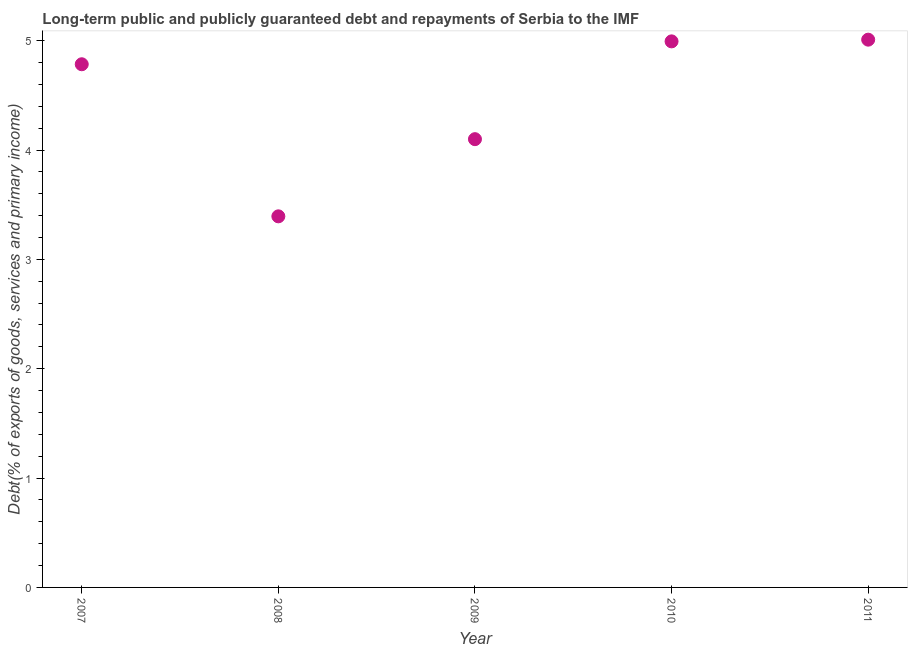What is the debt service in 2011?
Your answer should be very brief. 5.01. Across all years, what is the maximum debt service?
Offer a terse response. 5.01. Across all years, what is the minimum debt service?
Provide a short and direct response. 3.39. In which year was the debt service minimum?
Your answer should be very brief. 2008. What is the sum of the debt service?
Provide a short and direct response. 22.28. What is the difference between the debt service in 2010 and 2011?
Make the answer very short. -0.02. What is the average debt service per year?
Offer a terse response. 4.46. What is the median debt service?
Offer a very short reply. 4.78. In how many years, is the debt service greater than 2.6 %?
Your answer should be compact. 5. What is the ratio of the debt service in 2007 to that in 2009?
Provide a short and direct response. 1.17. What is the difference between the highest and the second highest debt service?
Your answer should be compact. 0.02. Is the sum of the debt service in 2007 and 2008 greater than the maximum debt service across all years?
Give a very brief answer. Yes. What is the difference between the highest and the lowest debt service?
Your answer should be very brief. 1.62. Does the debt service monotonically increase over the years?
Offer a terse response. No. How many dotlines are there?
Make the answer very short. 1. What is the difference between two consecutive major ticks on the Y-axis?
Provide a short and direct response. 1. Are the values on the major ticks of Y-axis written in scientific E-notation?
Keep it short and to the point. No. Does the graph contain grids?
Offer a very short reply. No. What is the title of the graph?
Offer a terse response. Long-term public and publicly guaranteed debt and repayments of Serbia to the IMF. What is the label or title of the X-axis?
Keep it short and to the point. Year. What is the label or title of the Y-axis?
Ensure brevity in your answer.  Debt(% of exports of goods, services and primary income). What is the Debt(% of exports of goods, services and primary income) in 2007?
Give a very brief answer. 4.78. What is the Debt(% of exports of goods, services and primary income) in 2008?
Offer a terse response. 3.39. What is the Debt(% of exports of goods, services and primary income) in 2009?
Make the answer very short. 4.1. What is the Debt(% of exports of goods, services and primary income) in 2010?
Your answer should be compact. 4.99. What is the Debt(% of exports of goods, services and primary income) in 2011?
Provide a succinct answer. 5.01. What is the difference between the Debt(% of exports of goods, services and primary income) in 2007 and 2008?
Your answer should be very brief. 1.39. What is the difference between the Debt(% of exports of goods, services and primary income) in 2007 and 2009?
Offer a very short reply. 0.68. What is the difference between the Debt(% of exports of goods, services and primary income) in 2007 and 2010?
Offer a very short reply. -0.21. What is the difference between the Debt(% of exports of goods, services and primary income) in 2007 and 2011?
Your response must be concise. -0.23. What is the difference between the Debt(% of exports of goods, services and primary income) in 2008 and 2009?
Give a very brief answer. -0.71. What is the difference between the Debt(% of exports of goods, services and primary income) in 2008 and 2010?
Your answer should be very brief. -1.6. What is the difference between the Debt(% of exports of goods, services and primary income) in 2008 and 2011?
Ensure brevity in your answer.  -1.62. What is the difference between the Debt(% of exports of goods, services and primary income) in 2009 and 2010?
Offer a terse response. -0.89. What is the difference between the Debt(% of exports of goods, services and primary income) in 2009 and 2011?
Your answer should be compact. -0.91. What is the difference between the Debt(% of exports of goods, services and primary income) in 2010 and 2011?
Your answer should be very brief. -0.02. What is the ratio of the Debt(% of exports of goods, services and primary income) in 2007 to that in 2008?
Make the answer very short. 1.41. What is the ratio of the Debt(% of exports of goods, services and primary income) in 2007 to that in 2009?
Your answer should be compact. 1.17. What is the ratio of the Debt(% of exports of goods, services and primary income) in 2007 to that in 2010?
Your answer should be compact. 0.96. What is the ratio of the Debt(% of exports of goods, services and primary income) in 2007 to that in 2011?
Keep it short and to the point. 0.95. What is the ratio of the Debt(% of exports of goods, services and primary income) in 2008 to that in 2009?
Provide a short and direct response. 0.83. What is the ratio of the Debt(% of exports of goods, services and primary income) in 2008 to that in 2010?
Keep it short and to the point. 0.68. What is the ratio of the Debt(% of exports of goods, services and primary income) in 2008 to that in 2011?
Offer a very short reply. 0.68. What is the ratio of the Debt(% of exports of goods, services and primary income) in 2009 to that in 2010?
Your response must be concise. 0.82. What is the ratio of the Debt(% of exports of goods, services and primary income) in 2009 to that in 2011?
Keep it short and to the point. 0.82. 